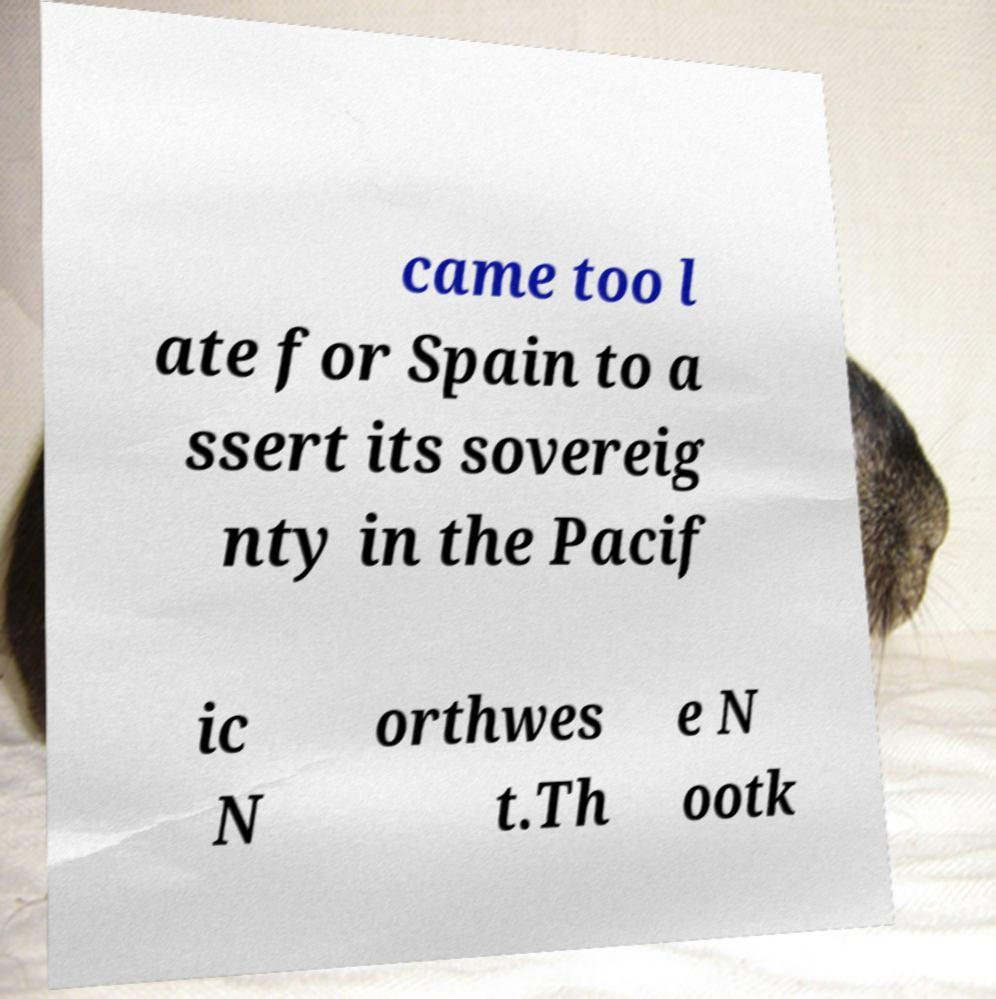Please read and relay the text visible in this image. What does it say? came too l ate for Spain to a ssert its sovereig nty in the Pacif ic N orthwes t.Th e N ootk 